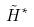Convert formula to latex. <formula><loc_0><loc_0><loc_500><loc_500>\tilde { H } ^ { * }</formula> 